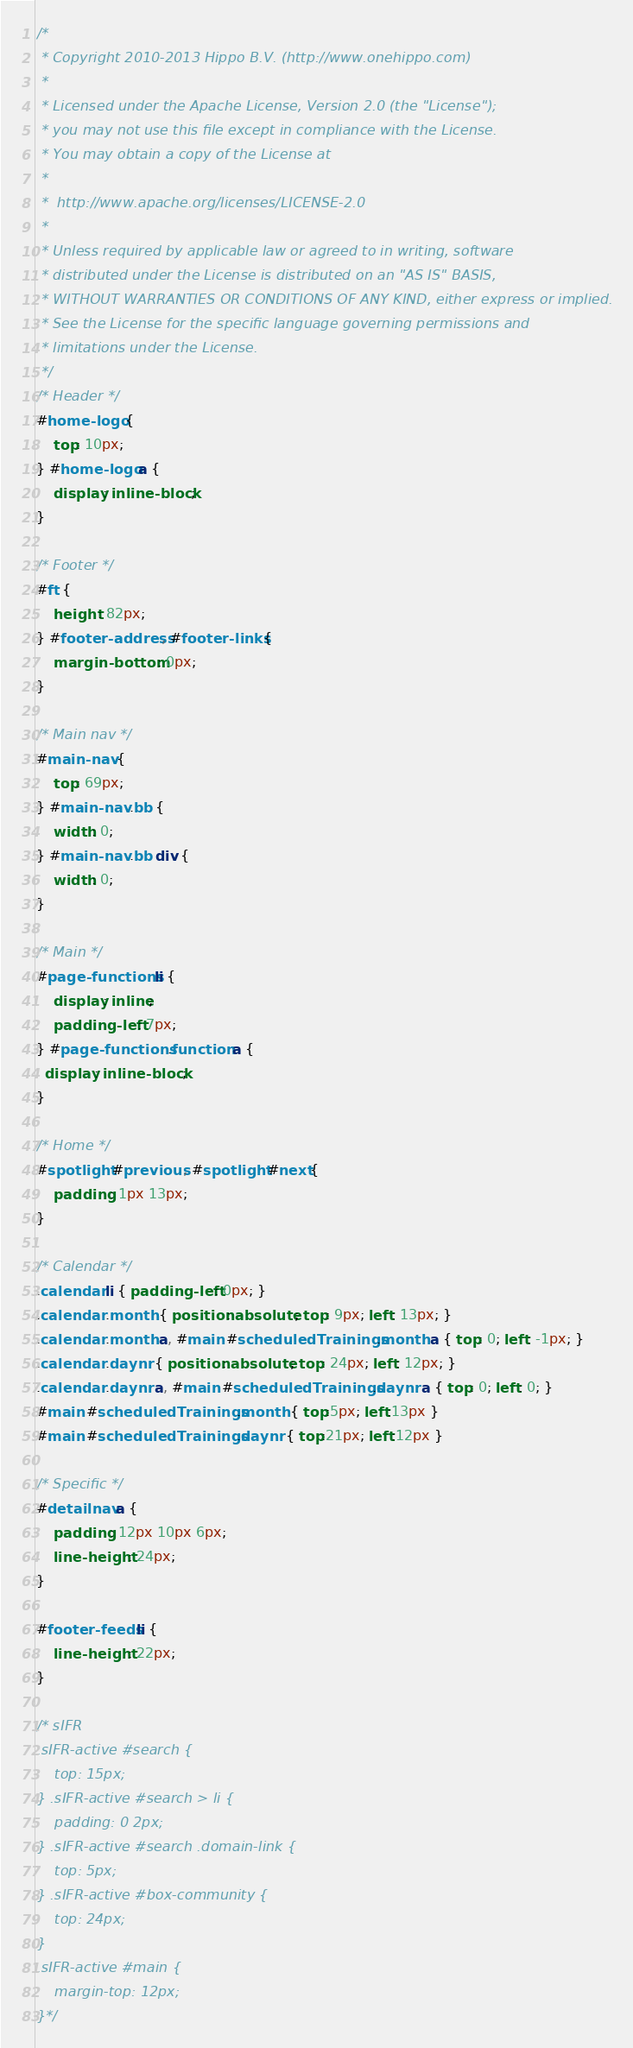<code> <loc_0><loc_0><loc_500><loc_500><_CSS_>/*
 * Copyright 2010-2013 Hippo B.V. (http://www.onehippo.com)
 *
 * Licensed under the Apache License, Version 2.0 (the "License");
 * you may not use this file except in compliance with the License.
 * You may obtain a copy of the License at
 *
 *  http://www.apache.org/licenses/LICENSE-2.0
 *
 * Unless required by applicable law or agreed to in writing, software
 * distributed under the License is distributed on an "AS IS" BASIS,
 * WITHOUT WARRANTIES OR CONDITIONS OF ANY KIND, either express or implied.
 * See the License for the specific language governing permissions and
 * limitations under the License.
 */
/* Header */
#home-logo {
	top: 10px;
} #home-logo a {
	display: inline-block;
}

/* Footer */
#ft {
    height: 82px;
} #footer-address, #footer-links {
    margin-bottom: 0px;
}

/* Main nav */
#main-nav {
    top: 69px;
} #main-nav .bb {
    width: 0;
} #main-nav .bb div {
    width: 0;
}

/* Main */
#page-functions li {
    display: inline;
    padding-left: 7px;
} #page-functions .function a {
  display: inline-block;
}

/* Home */
#spotlight #previous, #spotlight #next{
	padding: 1px 13px;
}

/* Calendar */
.calendar li { padding-left: 0px; }
.calendar .month { position: absolute; top: 9px; left: 13px; }
.calendar .month a, #main #scheduledTrainings .month a { top: 0; left: -1px; }
.calendar .daynr { position: absolute; top: 24px; left: 12px; }
.calendar .daynr a, #main #scheduledTrainings .daynr a { top: 0; left: 0; }
#main #scheduledTrainings .month { top:5px; left:13px }
#main #scheduledTrainings .daynr { top:21px; left:12px }

/* Specific */
#detailnav a {
	padding: 12px 10px 6px;
    line-height: 24px;
}

#footer-feeds li {
	line-height: 22px;
}

/* sIFR
.sIFR-active #search {
	top: 15px;
} .sIFR-active #search > li {
	padding: 0 2px;
} .sIFR-active #search .domain-link {
	top: 5px;
} .sIFR-active #box-community {
	top: 24px;
}
.sIFR-active #main {
	margin-top: 12px;
}*/</code> 